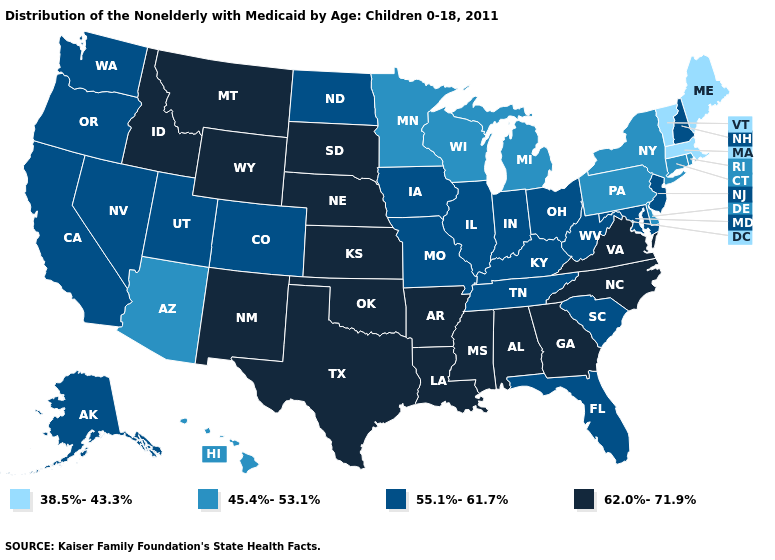Does Iowa have the highest value in the MidWest?
Keep it brief. No. Among the states that border Illinois , which have the lowest value?
Concise answer only. Wisconsin. Does Ohio have a higher value than New Jersey?
Answer briefly. No. Name the states that have a value in the range 55.1%-61.7%?
Short answer required. Alaska, California, Colorado, Florida, Illinois, Indiana, Iowa, Kentucky, Maryland, Missouri, Nevada, New Hampshire, New Jersey, North Dakota, Ohio, Oregon, South Carolina, Tennessee, Utah, Washington, West Virginia. What is the value of South Dakota?
Answer briefly. 62.0%-71.9%. Name the states that have a value in the range 62.0%-71.9%?
Concise answer only. Alabama, Arkansas, Georgia, Idaho, Kansas, Louisiana, Mississippi, Montana, Nebraska, New Mexico, North Carolina, Oklahoma, South Dakota, Texas, Virginia, Wyoming. Does West Virginia have a higher value than Pennsylvania?
Keep it brief. Yes. Among the states that border North Carolina , which have the lowest value?
Concise answer only. South Carolina, Tennessee. What is the lowest value in the Northeast?
Be succinct. 38.5%-43.3%. What is the value of Arkansas?
Give a very brief answer. 62.0%-71.9%. Which states have the highest value in the USA?
Quick response, please. Alabama, Arkansas, Georgia, Idaho, Kansas, Louisiana, Mississippi, Montana, Nebraska, New Mexico, North Carolina, Oklahoma, South Dakota, Texas, Virginia, Wyoming. Name the states that have a value in the range 55.1%-61.7%?
Quick response, please. Alaska, California, Colorado, Florida, Illinois, Indiana, Iowa, Kentucky, Maryland, Missouri, Nevada, New Hampshire, New Jersey, North Dakota, Ohio, Oregon, South Carolina, Tennessee, Utah, Washington, West Virginia. How many symbols are there in the legend?
Short answer required. 4. Does Rhode Island have the highest value in the USA?
Answer briefly. No. 